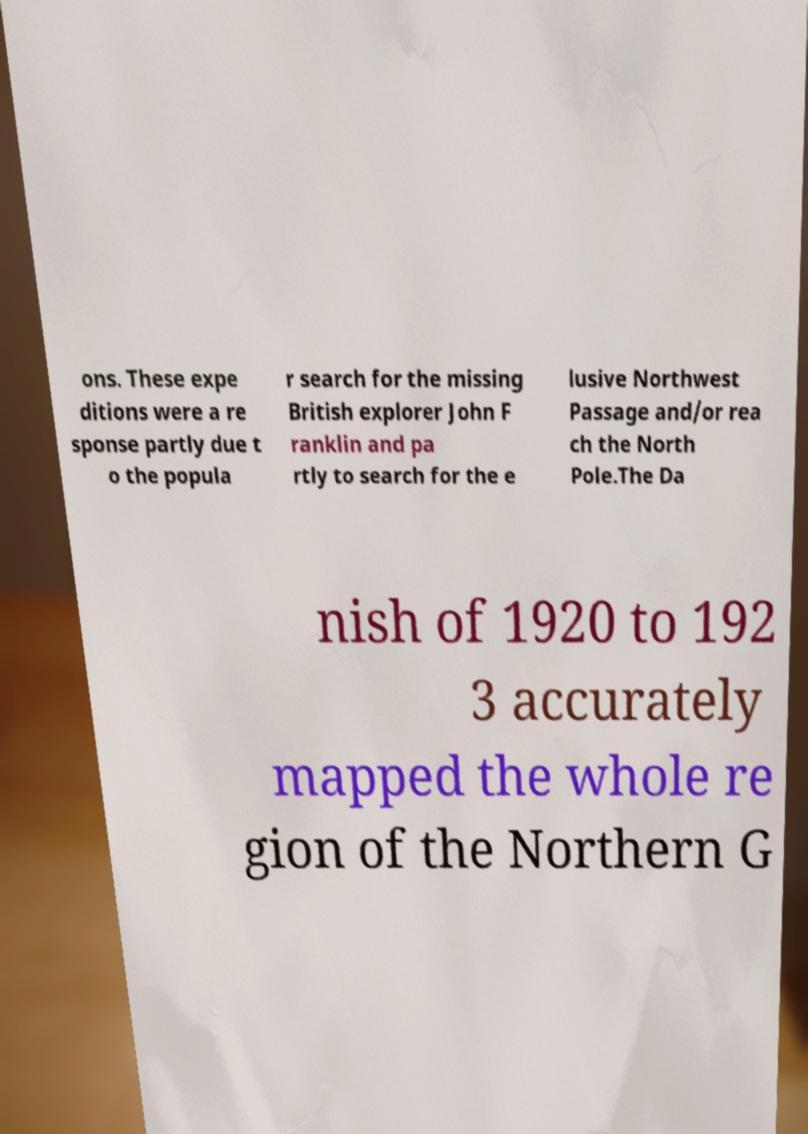Can you accurately transcribe the text from the provided image for me? ons. These expe ditions were a re sponse partly due t o the popula r search for the missing British explorer John F ranklin and pa rtly to search for the e lusive Northwest Passage and/or rea ch the North Pole.The Da nish of 1920 to 192 3 accurately mapped the whole re gion of the Northern G 